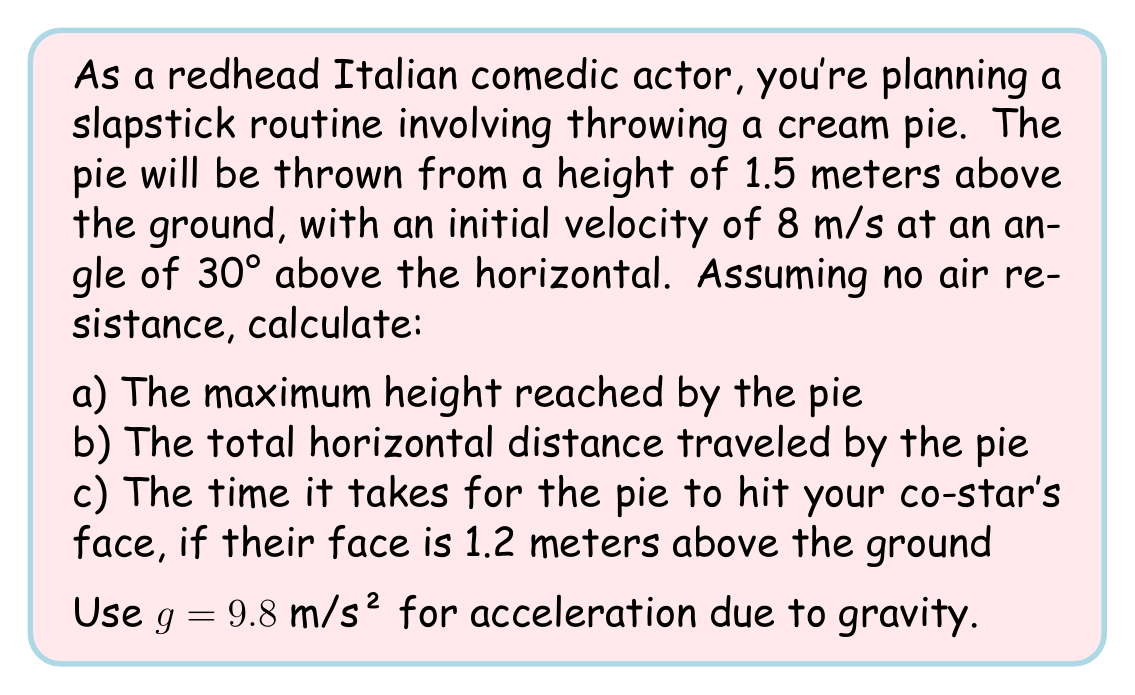Can you answer this question? Let's approach this problem step by step using the equations of projectile motion.

Given:
- Initial height ($h_0$) = 1.5 m
- Initial velocity ($v_0$) = 8 m/s
- Angle of projection ($\theta$) = 30°
- $g = 9.8$ m/s²

First, let's decompose the initial velocity into its horizontal and vertical components:

$v_{0x} = v_0 \cos(\theta) = 8 \cos(30°) = 6.93$ m/s
$v_{0y} = v_0 \sin(\theta) = 8 \sin(30°) = 4$ m/s

a) To find the maximum height:

Use the equation: $h_{max} = h_0 + \frac{v_{0y}^2}{2g}$

$h_{max} = 1.5 + \frac{4^2}{2(9.8)} = 1.5 + 0.82 = 2.32$ m

b) For the total horizontal distance:

We need to find the time of flight first. The pie reaches the ground when $y = 0$:

$y = h_0 + v_{0y}t - \frac{1}{2}gt^2$

$0 = 1.5 + 4t - \frac{1}{2}(9.8)t^2$

Solving this quadratic equation:

$t = \frac{4 + \sqrt{16 + 4(9.8)(1.5)}}{9.8} = 1.18$ s

Now, the horizontal distance:

$x = v_{0x}t = 6.93 \times 1.18 = 8.18$ m

c) For the time to hit the co-star's face:

We use the same equation as in (b), but with $y = 1.2$ m:

$1.2 = 1.5 + 4t - \frac{1}{2}(9.8)t^2$

Solving this quadratic equation:

$t = \frac{4 - \sqrt{16 + 4(9.8)(0.3)}}{9.8} = 0.30$ s
Answer: a) Maximum height: 2.32 m
b) Total horizontal distance: 8.18 m
c) Time to hit co-star's face: 0.30 s 